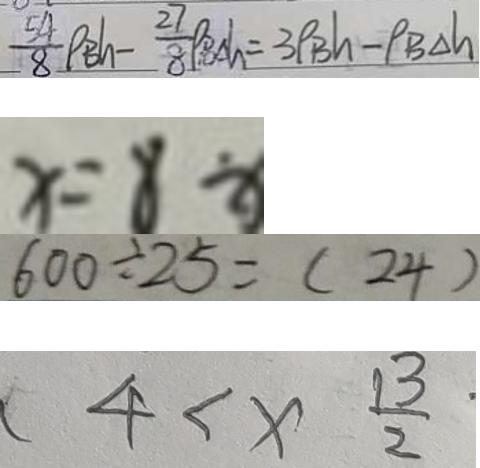<formula> <loc_0><loc_0><loc_500><loc_500>\frac { 5 4 } { 8 } \rho _ { B h } - \frac { 2 7 } { 8 } \rho _ { B \Delta h } = 3 \rho _ { B } h - \rho _ { B \Delta h } 
 x = 8 \div 
 6 0 0 \div 2 5 = ( 2 4 ) 
 4 < x \frac { 1 3 } { 2 }</formula> 